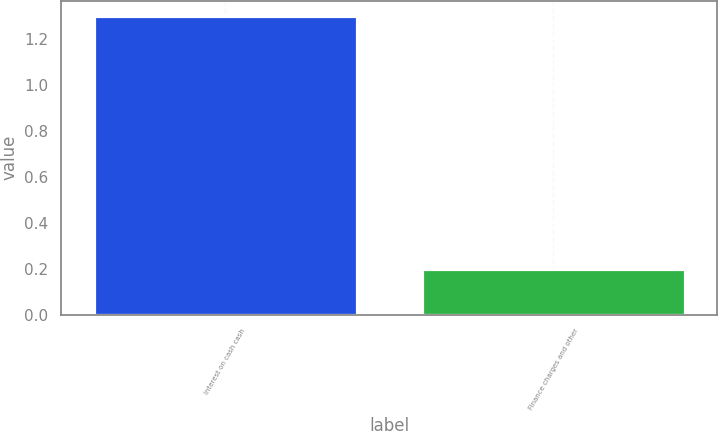Convert chart to OTSL. <chart><loc_0><loc_0><loc_500><loc_500><bar_chart><fcel>Interest on cash cash<fcel>Finance charges and other<nl><fcel>1.3<fcel>0.2<nl></chart> 